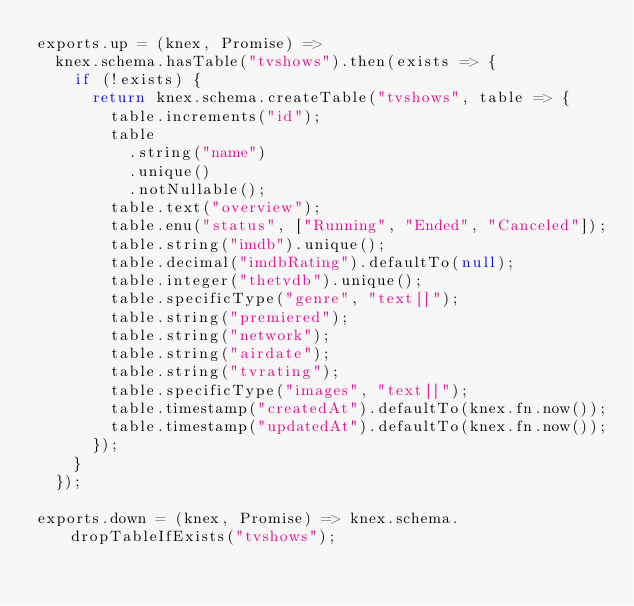Convert code to text. <code><loc_0><loc_0><loc_500><loc_500><_JavaScript_>exports.up = (knex, Promise) =>
  knex.schema.hasTable("tvshows").then(exists => {
    if (!exists) {
      return knex.schema.createTable("tvshows", table => {
        table.increments("id");
        table
          .string("name")
          .unique()
          .notNullable();
        table.text("overview");
        table.enu("status", ["Running", "Ended", "Canceled"]);
        table.string("imdb").unique();
        table.decimal("imdbRating").defaultTo(null);
        table.integer("thetvdb").unique();
        table.specificType("genre", "text[]");
        table.string("premiered");
        table.string("network");
        table.string("airdate");
        table.string("tvrating");
        table.specificType("images", "text[]");
        table.timestamp("createdAt").defaultTo(knex.fn.now());
        table.timestamp("updatedAt").defaultTo(knex.fn.now());
      });
    }
  });

exports.down = (knex, Promise) => knex.schema.dropTableIfExists("tvshows");
</code> 